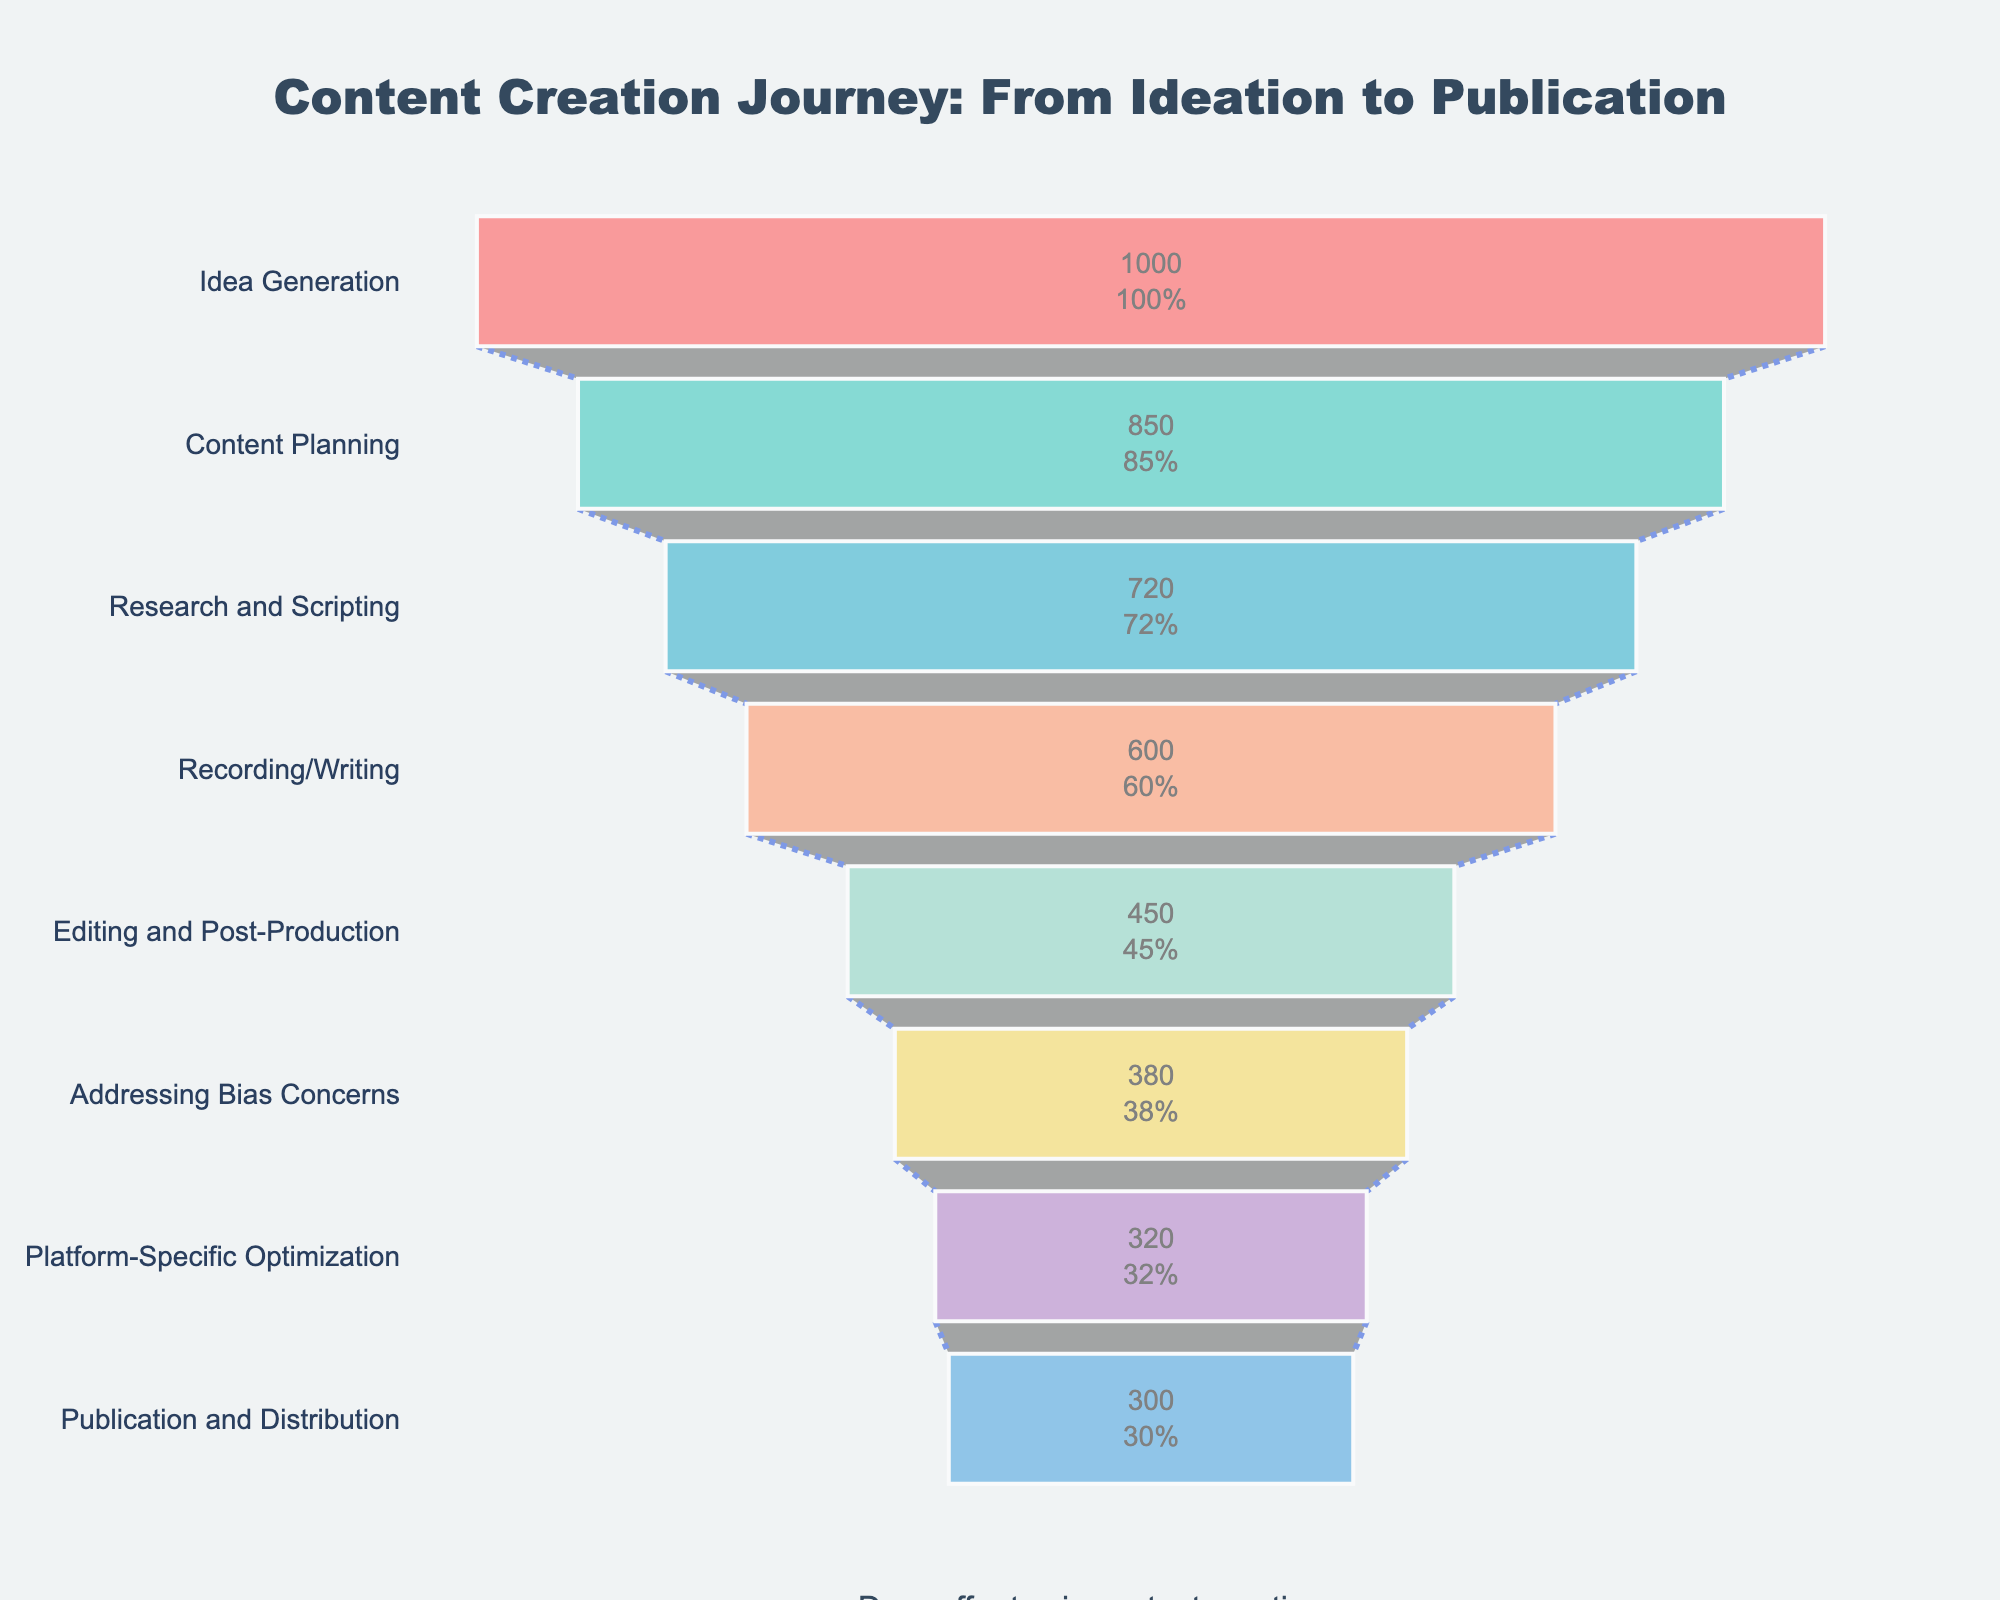What is the title of the funnel chart? The title is located at the top center of the chart and reads "Content Creation Journey: From Ideation to Publication"
Answer: Content Creation Journey: From Ideation to Publication How many stages are depicted in the funnel chart? By counting the number of stages labeled on the y-axis, you can determine that there are 8 stages listed from top to bottom
Answer: 8 Which stage sees the highest drop-off rate from the previous stage? By comparing the numbers of creators at each stage, the largest drop-off occurs between Recording/Writing (600) and Editing and Post-Production (450). The difference is 600 - 450 = 150 creators
Answer: Recording/Writing to Editing and Post-Production What percentage of the initial 1000 creators reach the final stage of Publication and Distribution? The number of creators at the final stage is 300. To find the percentage, divide 300 by 1000 and multiply by 100, which is (300/1000) * 100 = 30%
Answer: 30% How many creators drop off between the Content Planning and Research and Scripting stages? Subtract the number of creators in the Research and Scripting stage (720) from the number in Content Planning (850), which is 850 - 720 = 130
Answer: 130 Which stage directly follows Research and Scripting in the content creation process? By following the sequence of labels on the y-axis, the stage after Research and Scripting is Recording/Writing
Answer: Recording/Writing Is there a greater drop-off in the number of creators between Content Planning and Research and Scripting or between Research and Scripting and Recording/Writing? Calculate the drop-offs: Content Planning to Research and Scripting is 850 - 720 = 130. Research and Scripting to Recording/Writing is 720 - 600 = 120. Comparing these, 130 is greater than 120
Answer: Content Planning to Research and Scripting What is the total number of creators who drop off from the initial idea generation till Publication and Distribution? Sum the differences between consecutive stages: 
(1000 - 850) + (850 - 720) + (720 - 600) + (600 - 450) + (450 - 380) + (380 - 320) + (320 - 300) = 150 + 130 + 120 + 150 + 70 + 60 + 20 = 700
Answer: 700 At which stage do fewer than half of the initial creators remain? 1000/2 = 500, so identify the first stage with fewer than 500 creators. That stage is Addressing Bias Concerns with 380 creators remaining
Answer: Addressing Bias Concerns 